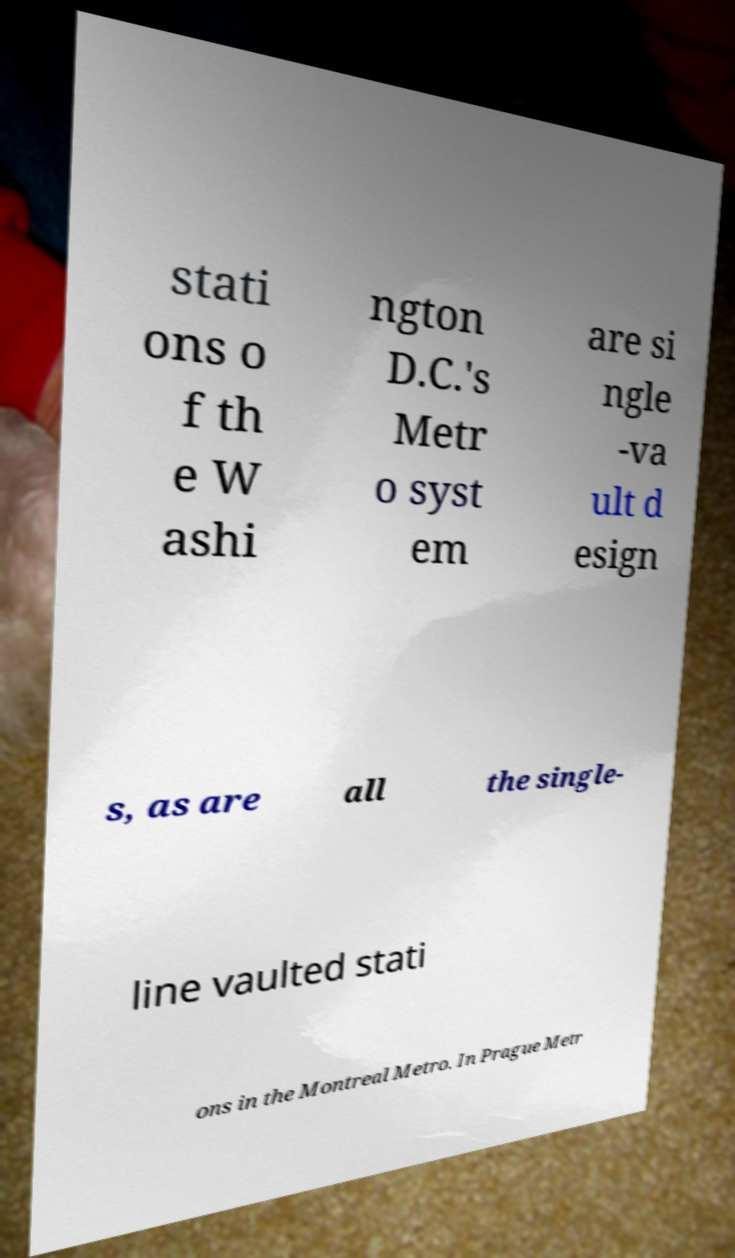Please read and relay the text visible in this image. What does it say? stati ons o f th e W ashi ngton D.C.'s Metr o syst em are si ngle -va ult d esign s, as are all the single- line vaulted stati ons in the Montreal Metro. In Prague Metr 